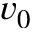Convert formula to latex. <formula><loc_0><loc_0><loc_500><loc_500>v _ { 0 }</formula> 